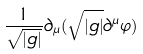<formula> <loc_0><loc_0><loc_500><loc_500>\frac { 1 } { \sqrt { | g | } } \partial _ { \mu } ( \sqrt { | g | } \partial ^ { \mu } \varphi )</formula> 